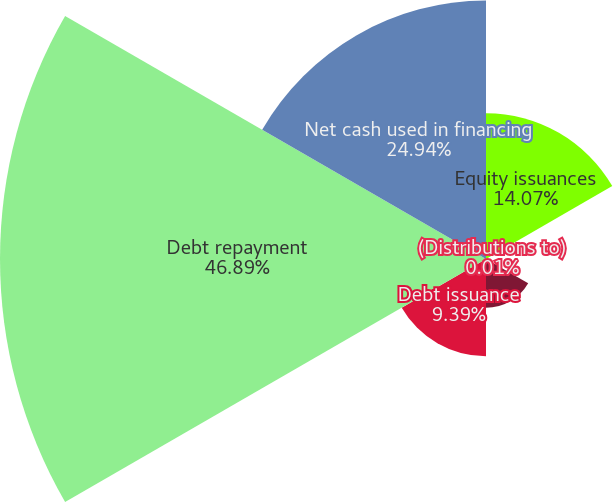<chart> <loc_0><loc_0><loc_500><loc_500><pie_chart><fcel>Equity issuances<fcel>(Distributions to)<fcel>Dividend payments<fcel>Debt issuance<fcel>Debt repayment<fcel>Net cash used in financing<nl><fcel>14.07%<fcel>0.01%<fcel>4.7%<fcel>9.39%<fcel>46.9%<fcel>24.94%<nl></chart> 